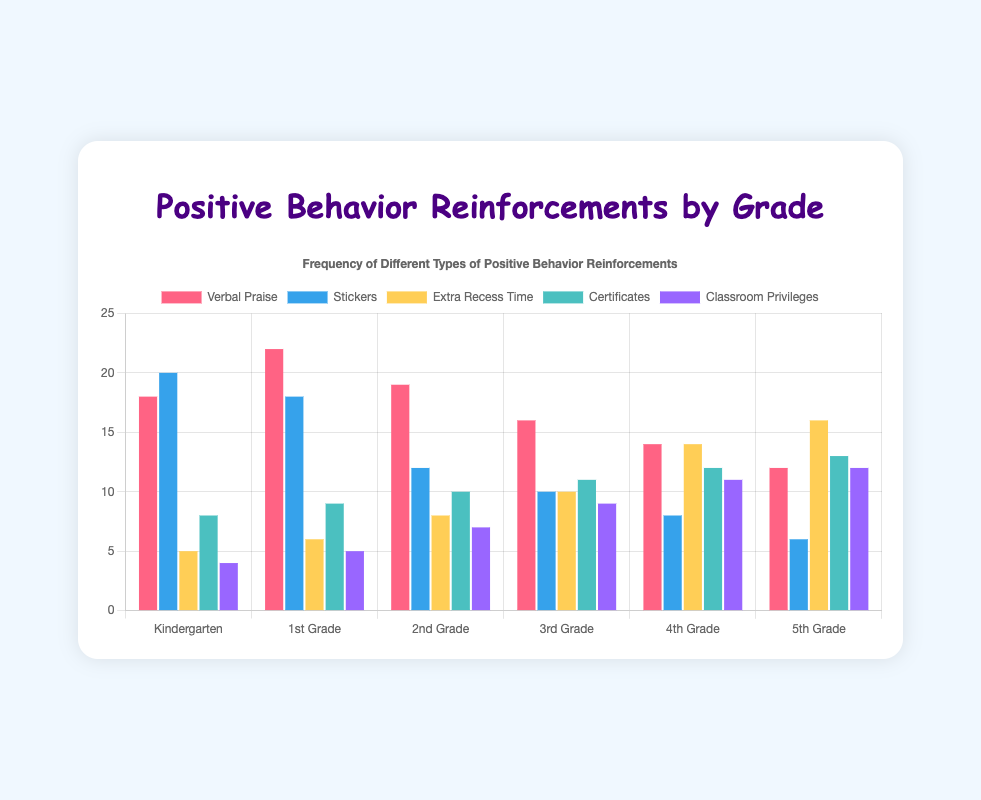What grade level uses Verbal Praise the most? According to the chart, the highest bar for Verbal Praise is associated with 1st Grade, indicating it is used the most at that level.
Answer: 1st Grade How many more times is Verbal Praise used in Kindergarten compared to 5th Grade? To find this, subtract the frequency of Verbal Praise in 5th Grade (12) from that in Kindergarten (18). 18 - 12 = 6.
Answer: 6 Which type of positive behavior reinforcement shows increasing use as the grade level goes up? Observing the chart, Extra Recess Time shows a clear increase in usage from Kindergarten to 5th Grade.
Answer: Extra Recess Time What is the combined total of certificates given across all grades? Add the number of certificates given in each grade: 8 (Kindergarten) + 9 (1st Grade) + 10 (2nd Grade) + 11 (3rd Grade) + 12 (4th Grade) + 13 (5th Grade) = 63.
Answer: 63 In which grade are Stickers used more often than Verbal Praise? By comparing the bars for Stickers and Verbal Praise for each grade, in Kindergarten, Stickers (20) are used more than Verbal Praise (18).
Answer: Kindergarten Which grade has the least frequent use of Classroom Privileges? The shortest bar for Classroom Privileges corresponds to Kindergarten, where it's used 4 times.
Answer: Kindergarten In 4th Grade, which is more frequent: Extra Recess Time or Classroom Privileges? Comparing the heights of the bars for 4th Grade, Extra Recess Time (14) is higher than Classroom Privileges (11).
Answer: Extra Recess Time How does the frequency of Verbal Praise change from Kindergarten to 5th Grade? Verbal Praise decreases step-by-step from 18 in Kindergarten to 12 in 5th Grade.
Answer: Decreases Across all grades, which type of behavior reinforcement has the most stable usage? Classroom Privileges has the most consistent increase without fluctuating much over the grades from 4 to 12.
Answer: Classroom Privileges 